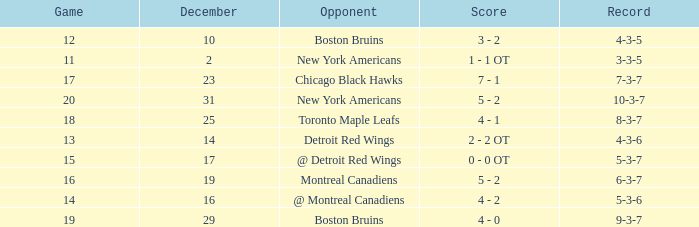Which December has a Record of 4-3-6? 14.0. 